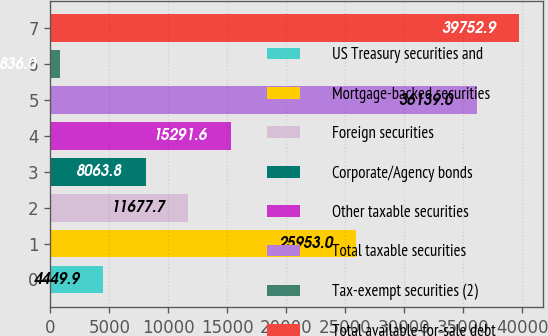<chart> <loc_0><loc_0><loc_500><loc_500><bar_chart><fcel>US Treasury securities and<fcel>Mortgage-backed securities<fcel>Foreign securities<fcel>Corporate/Agency bonds<fcel>Other taxable securities<fcel>Total taxable securities<fcel>Tax-exempt securities (2)<fcel>Total available-for-sale debt<nl><fcel>4449.9<fcel>25953<fcel>11677.7<fcel>8063.8<fcel>15291.6<fcel>36139<fcel>836<fcel>39752.9<nl></chart> 